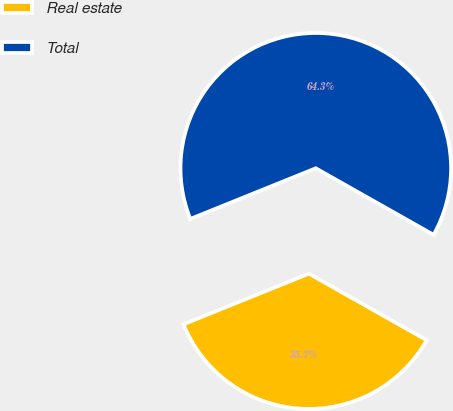Convert chart. <chart><loc_0><loc_0><loc_500><loc_500><pie_chart><fcel>Real estate<fcel>Total<nl><fcel>35.71%<fcel>64.29%<nl></chart> 